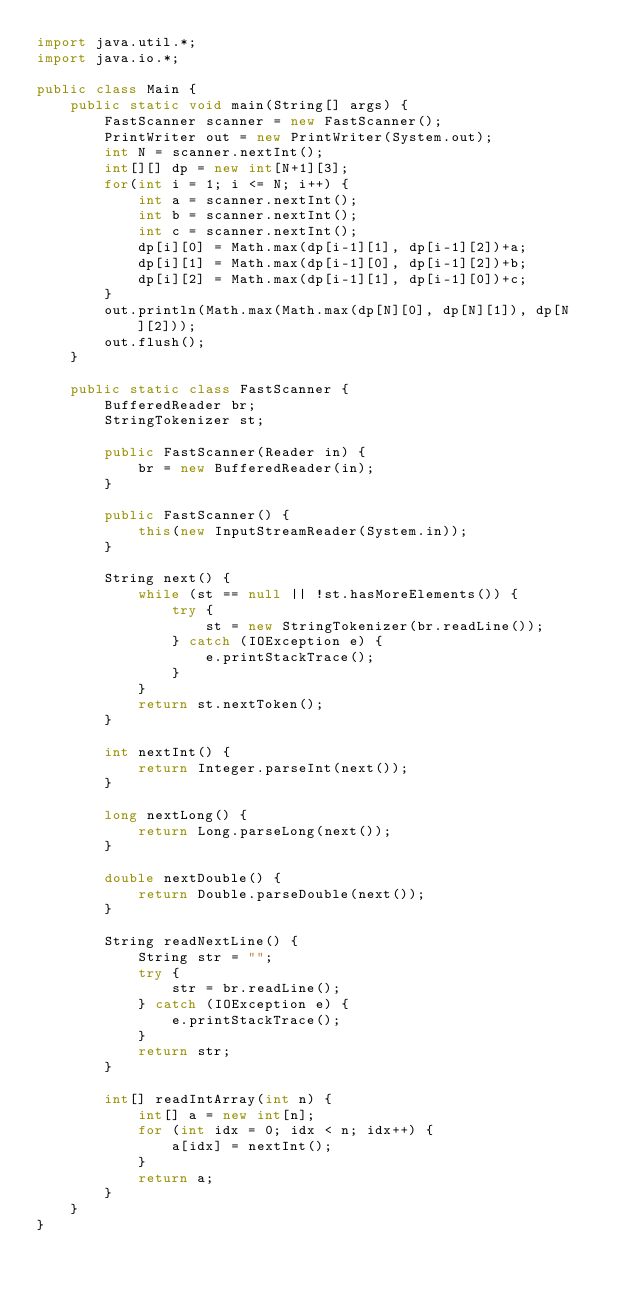<code> <loc_0><loc_0><loc_500><loc_500><_Java_>import java.util.*;
import java.io.*;

public class Main {
    public static void main(String[] args) {
        FastScanner scanner = new FastScanner();
        PrintWriter out = new PrintWriter(System.out);
        int N = scanner.nextInt();
        int[][] dp = new int[N+1][3];
        for(int i = 1; i <= N; i++) {
            int a = scanner.nextInt();
            int b = scanner.nextInt();
            int c = scanner.nextInt();
            dp[i][0] = Math.max(dp[i-1][1], dp[i-1][2])+a;
            dp[i][1] = Math.max(dp[i-1][0], dp[i-1][2])+b;
            dp[i][2] = Math.max(dp[i-1][1], dp[i-1][0])+c;
        }
        out.println(Math.max(Math.max(dp[N][0], dp[N][1]), dp[N][2]));
        out.flush();
    }
    
    public static class FastScanner {
        BufferedReader br;
        StringTokenizer st;
        
        public FastScanner(Reader in) {
            br = new BufferedReader(in);
        }
        
        public FastScanner() {
            this(new InputStreamReader(System.in));
        }
        
        String next() {
            while (st == null || !st.hasMoreElements()) {
                try {
                    st = new StringTokenizer(br.readLine());
                } catch (IOException e) {
                    e.printStackTrace();
                }
            }
            return st.nextToken();
        }
        
        int nextInt() {
            return Integer.parseInt(next());
        }
        
        long nextLong() {
            return Long.parseLong(next());
        }
        
        double nextDouble() {
            return Double.parseDouble(next());
        }
        
        String readNextLine() {
            String str = "";
            try {
                str = br.readLine();
            } catch (IOException e) {
                e.printStackTrace();
            }
            return str;
        }
        
        int[] readIntArray(int n) {
            int[] a = new int[n];
            for (int idx = 0; idx < n; idx++) {
                a[idx] = nextInt();
            }
            return a;
        }
    }
}
</code> 